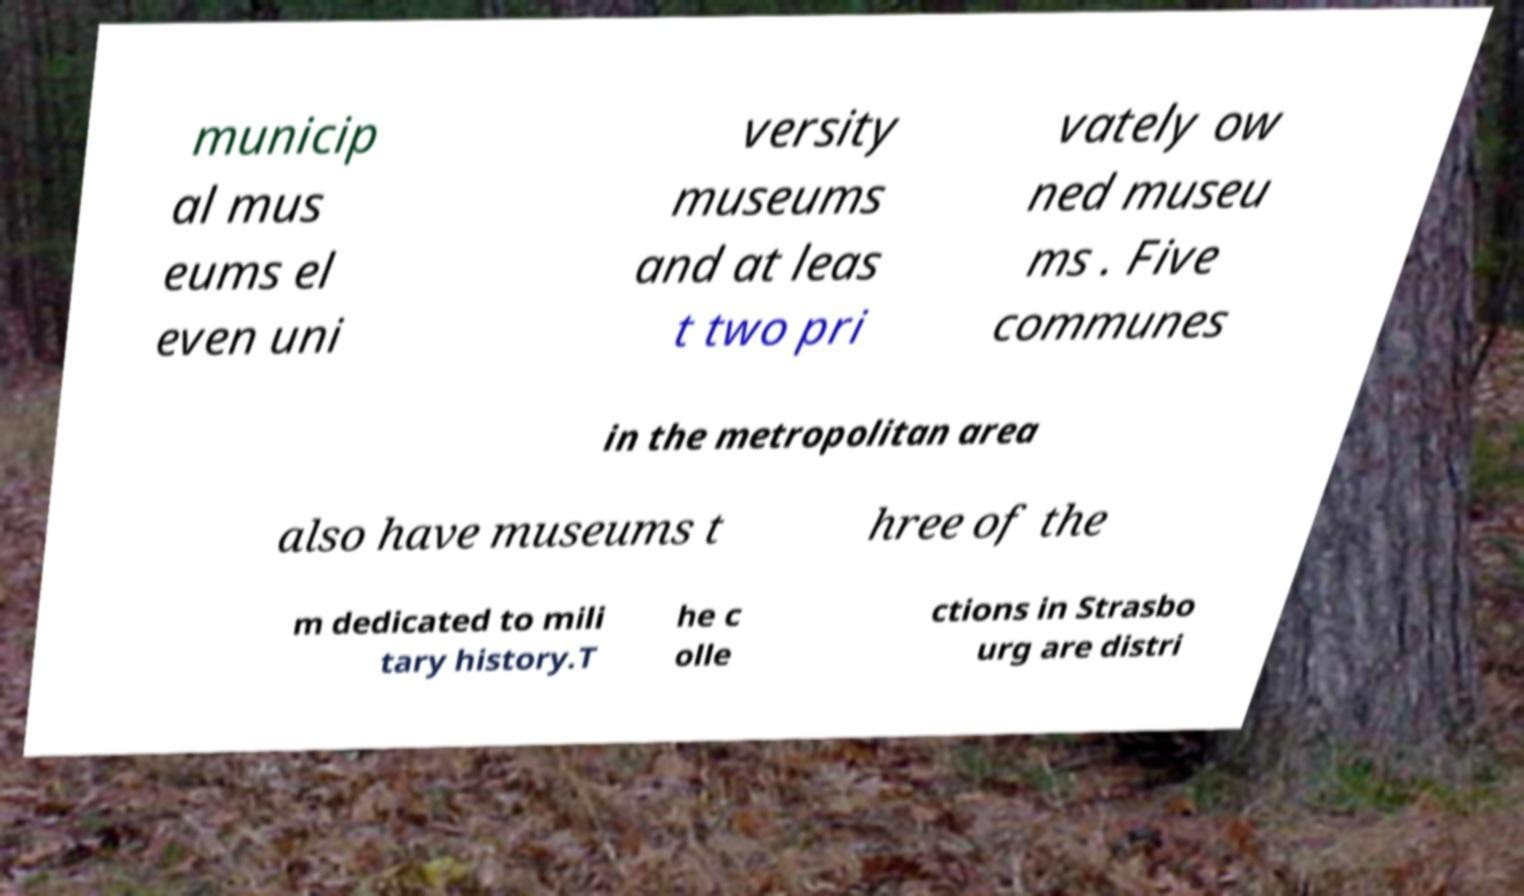I need the written content from this picture converted into text. Can you do that? municip al mus eums el even uni versity museums and at leas t two pri vately ow ned museu ms . Five communes in the metropolitan area also have museums t hree of the m dedicated to mili tary history.T he c olle ctions in Strasbo urg are distri 